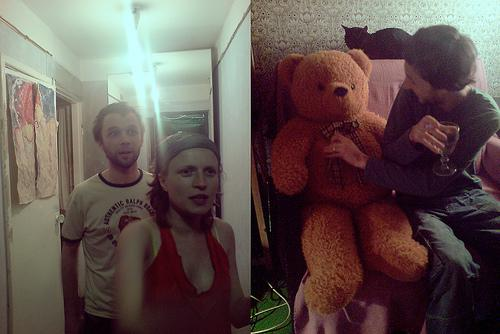Question: where is the cat?
Choices:
A. On the table.
B. Outside.
C. Top of chair.
D. On a bed.
Answer with the letter. Answer: C Question: how many people are in the image?
Choices:
A. Two.
B. Three.
C. One.
D. Four.
Answer with the letter. Answer: B Question: who is wearing the red top?
Choices:
A. The man.
B. The woman.
C. The baby.
D. The little girl.
Answer with the letter. Answer: B 